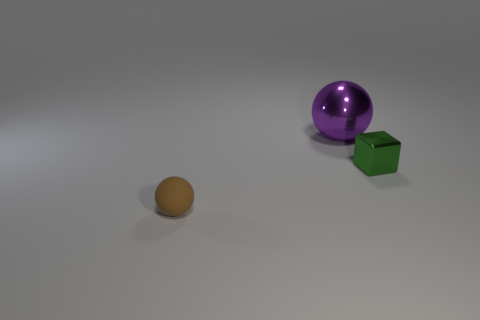Add 2 tiny purple matte cylinders. How many objects exist? 5 Subtract all cubes. How many objects are left? 2 Add 2 small cubes. How many small cubes exist? 3 Subtract 0 cyan cubes. How many objects are left? 3 Subtract all brown spheres. Subtract all tiny shiny objects. How many objects are left? 1 Add 1 metallic things. How many metallic things are left? 3 